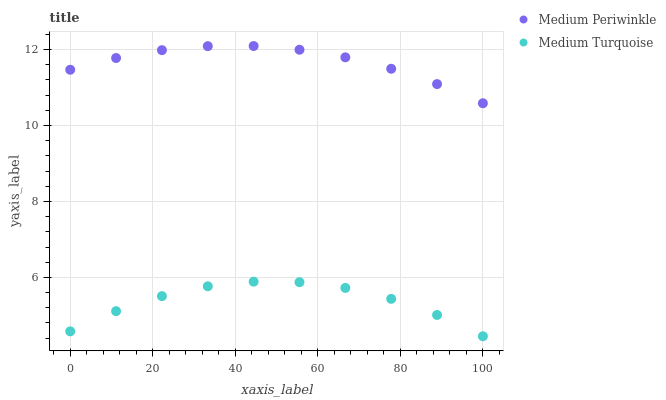Does Medium Turquoise have the minimum area under the curve?
Answer yes or no. Yes. Does Medium Periwinkle have the maximum area under the curve?
Answer yes or no. Yes. Does Medium Turquoise have the maximum area under the curve?
Answer yes or no. No. Is Medium Periwinkle the smoothest?
Answer yes or no. Yes. Is Medium Turquoise the roughest?
Answer yes or no. Yes. Is Medium Turquoise the smoothest?
Answer yes or no. No. Does Medium Turquoise have the lowest value?
Answer yes or no. Yes. Does Medium Periwinkle have the highest value?
Answer yes or no. Yes. Does Medium Turquoise have the highest value?
Answer yes or no. No. Is Medium Turquoise less than Medium Periwinkle?
Answer yes or no. Yes. Is Medium Periwinkle greater than Medium Turquoise?
Answer yes or no. Yes. Does Medium Turquoise intersect Medium Periwinkle?
Answer yes or no. No. 